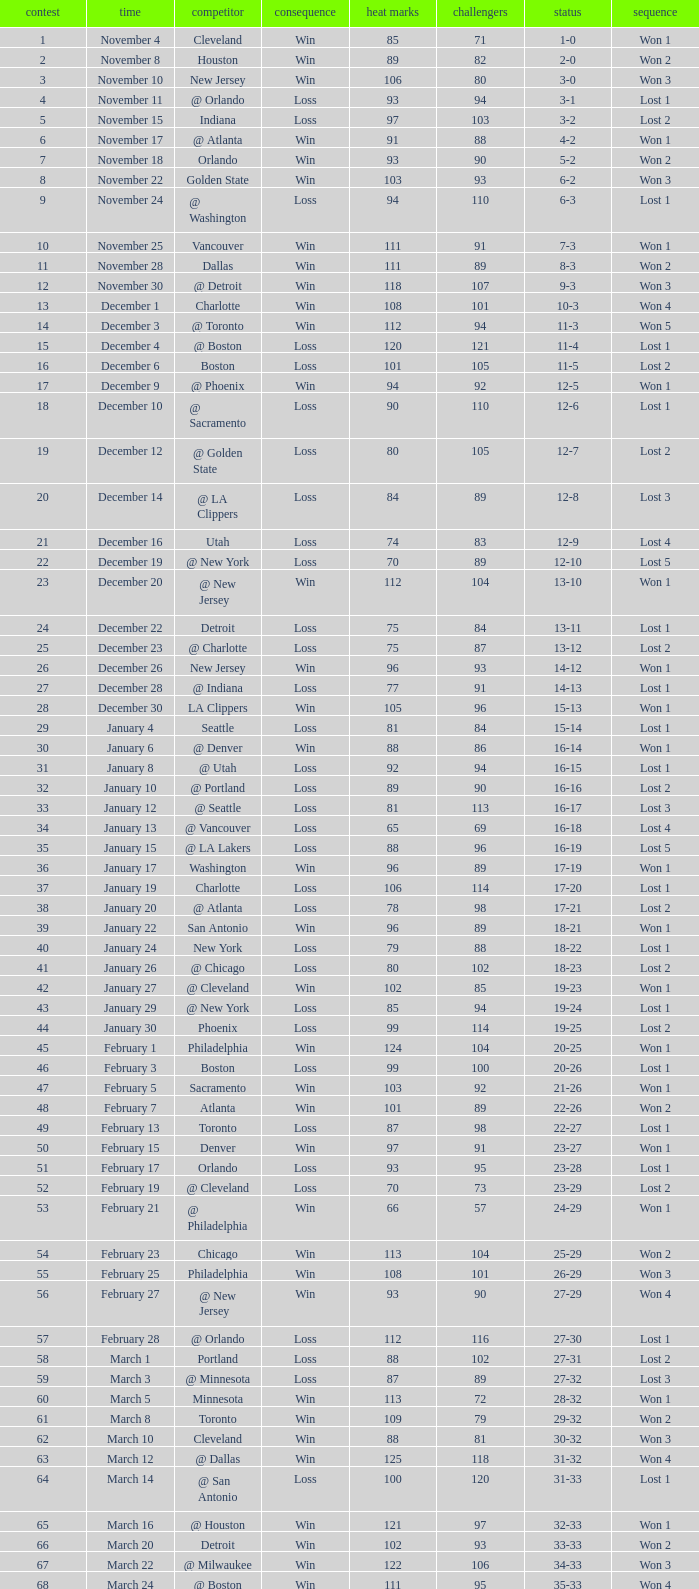What is Result, when Date is "December 12"? Loss. 